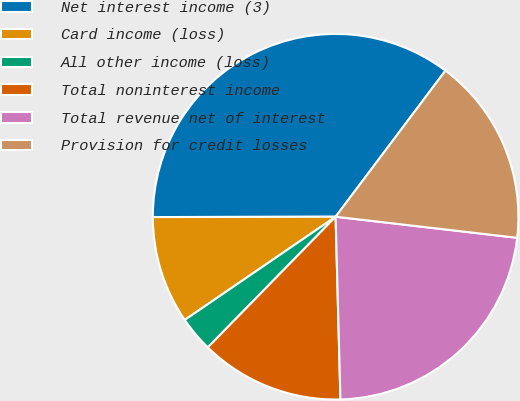Convert chart. <chart><loc_0><loc_0><loc_500><loc_500><pie_chart><fcel>Net interest income (3)<fcel>Card income (loss)<fcel>All other income (loss)<fcel>Total noninterest income<fcel>Total revenue net of interest<fcel>Provision for credit losses<nl><fcel>35.29%<fcel>9.52%<fcel>3.13%<fcel>12.74%<fcel>22.74%<fcel>16.58%<nl></chart> 